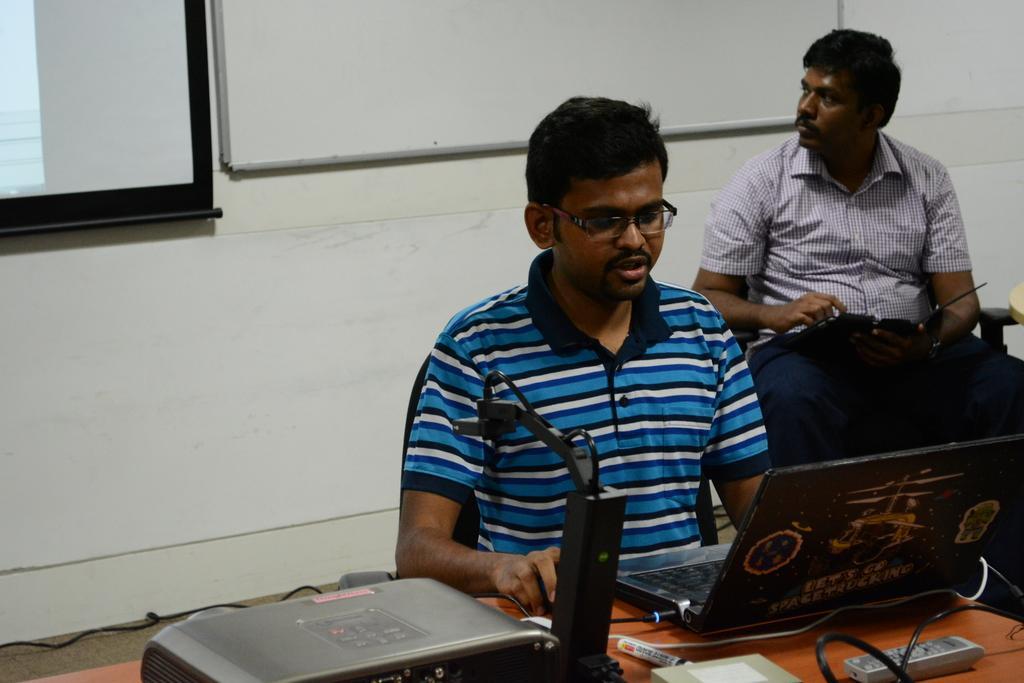In one or two sentences, can you explain what this image depicts? There are two men sitting on the chairs. This is a table with a laptop, marker pen, remote, electronic device and few other objects on it. This looks like a whiteboard, which is attached to the wall. I think this is the screen. 